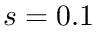<formula> <loc_0><loc_0><loc_500><loc_500>s = 0 . 1</formula> 